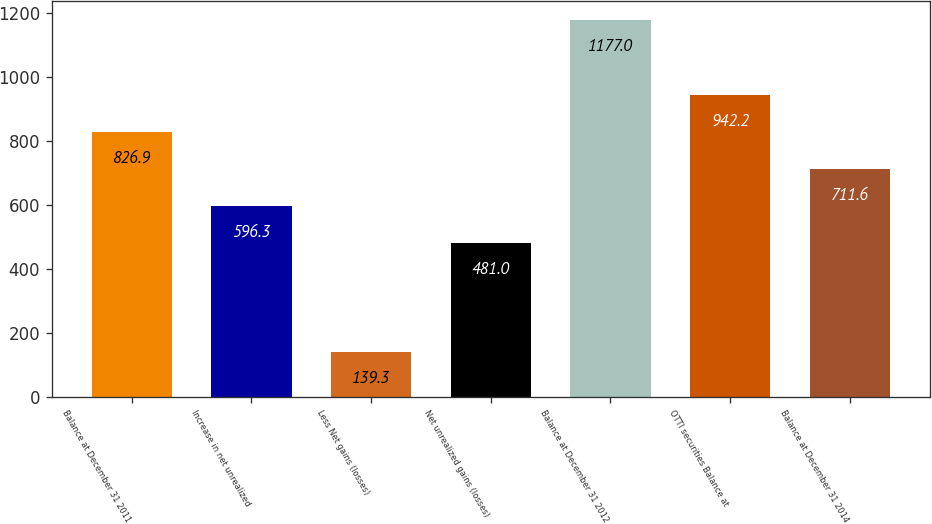<chart> <loc_0><loc_0><loc_500><loc_500><bar_chart><fcel>Balance at December 31 2011<fcel>Increase in net unrealized<fcel>Less Net gains (losses)<fcel>Net unrealized gains (losses)<fcel>Balance at December 31 2012<fcel>OTTI securities Balance at<fcel>Balance at December 31 2014<nl><fcel>826.9<fcel>596.3<fcel>139.3<fcel>481<fcel>1177<fcel>942.2<fcel>711.6<nl></chart> 